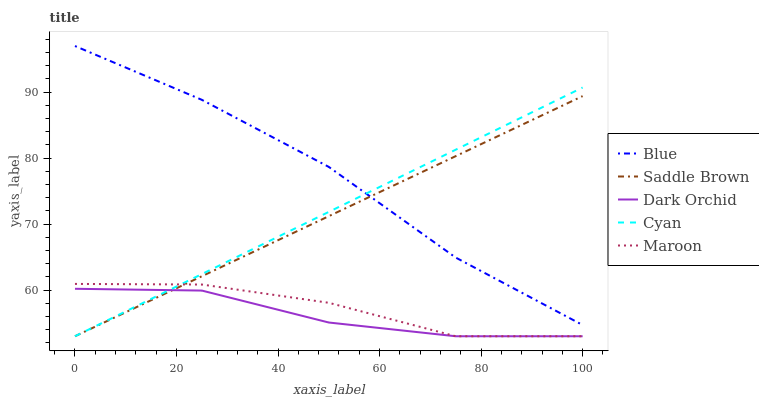Does Dark Orchid have the minimum area under the curve?
Answer yes or no. Yes. Does Blue have the maximum area under the curve?
Answer yes or no. Yes. Does Cyan have the minimum area under the curve?
Answer yes or no. No. Does Cyan have the maximum area under the curve?
Answer yes or no. No. Is Cyan the smoothest?
Answer yes or no. Yes. Is Maroon the roughest?
Answer yes or no. Yes. Is Maroon the smoothest?
Answer yes or no. No. Is Cyan the roughest?
Answer yes or no. No. Does Cyan have the lowest value?
Answer yes or no. Yes. Does Blue have the highest value?
Answer yes or no. Yes. Does Cyan have the highest value?
Answer yes or no. No. Is Maroon less than Blue?
Answer yes or no. Yes. Is Blue greater than Dark Orchid?
Answer yes or no. Yes. Does Cyan intersect Blue?
Answer yes or no. Yes. Is Cyan less than Blue?
Answer yes or no. No. Is Cyan greater than Blue?
Answer yes or no. No. Does Maroon intersect Blue?
Answer yes or no. No. 